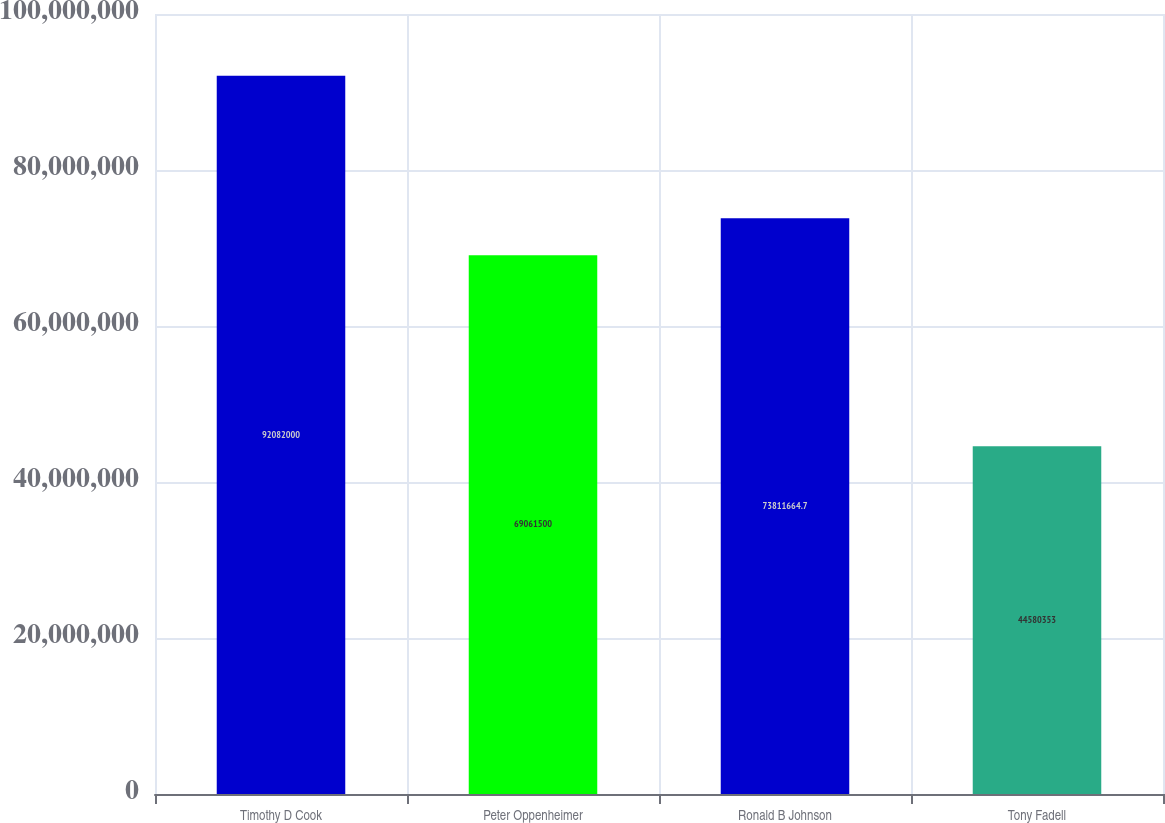Convert chart. <chart><loc_0><loc_0><loc_500><loc_500><bar_chart><fcel>Timothy D Cook<fcel>Peter Oppenheimer<fcel>Ronald B Johnson<fcel>Tony Fadell<nl><fcel>9.2082e+07<fcel>6.90615e+07<fcel>7.38117e+07<fcel>4.45804e+07<nl></chart> 